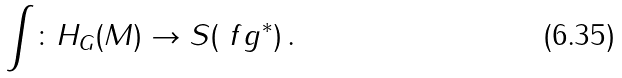<formula> <loc_0><loc_0><loc_500><loc_500>\int \colon H _ { G } ( M ) \to S ( \ f g ^ { * } ) \, .</formula> 